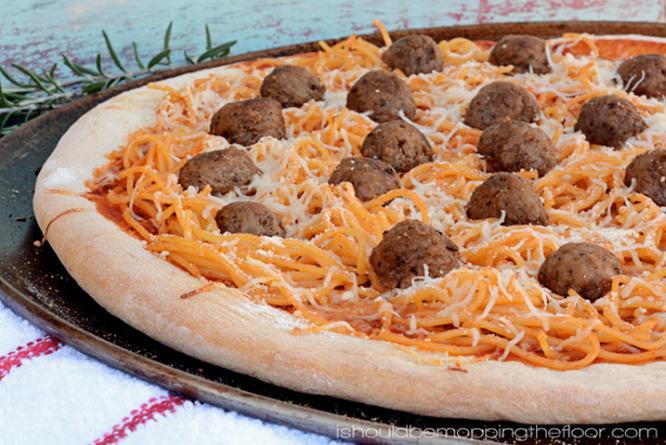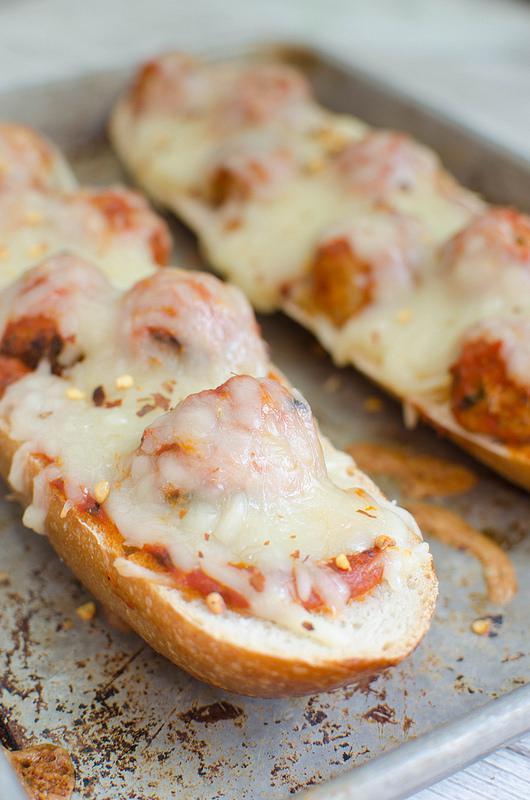The first image is the image on the left, the second image is the image on the right. Given the left and right images, does the statement "The pizza in both images is french bread pizza." hold true? Answer yes or no. No. The first image is the image on the left, the second image is the image on the right. Examine the images to the left and right. Is the description "The left image shows a round pizza topped with meatballs, and the right image shows individual 'pizzas' with topping on bread." accurate? Answer yes or no. Yes. 